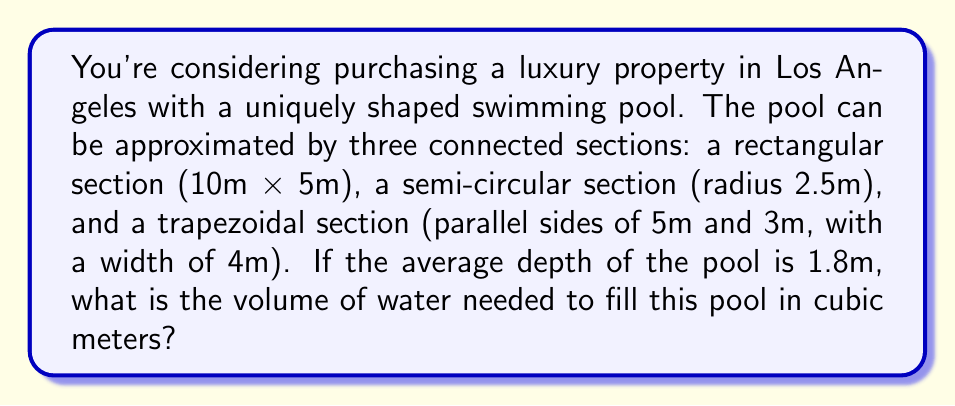Could you help me with this problem? To calculate the volume of the irregularly shaped pool, we need to:
1. Calculate the area of each section
2. Sum the areas
3. Multiply the total area by the average depth

Let's break it down step-by-step:

1. Area of rectangular section:
   $A_r = l \times w = 10 \text{ m} \times 5 \text{ m} = 50 \text{ m}^2$

2. Area of semi-circular section:
   $A_s = \frac{1}{2} \pi r^2 = \frac{1}{2} \times \pi \times (2.5 \text{ m})^2 = 9.82 \text{ m}^2$

3. Area of trapezoidal section:
   $A_t = \frac{a+b}{2} \times h = \frac{5 \text{ m} + 3 \text{ m}}{2} \times 4 \text{ m} = 16 \text{ m}^2$

4. Total surface area:
   $A_{total} = A_r + A_s + A_t = 50 \text{ m}^2 + 9.82 \text{ m}^2 + 16 \text{ m}^2 = 75.82 \text{ m}^2$

5. Volume calculation:
   $V = A_{total} \times \text{depth} = 75.82 \text{ m}^2 \times 1.8 \text{ m} = 136.48 \text{ m}^3$

Therefore, the volume of water needed to fill the pool is approximately 136.48 cubic meters.
Answer: $$136.48 \text{ m}^3$$ 